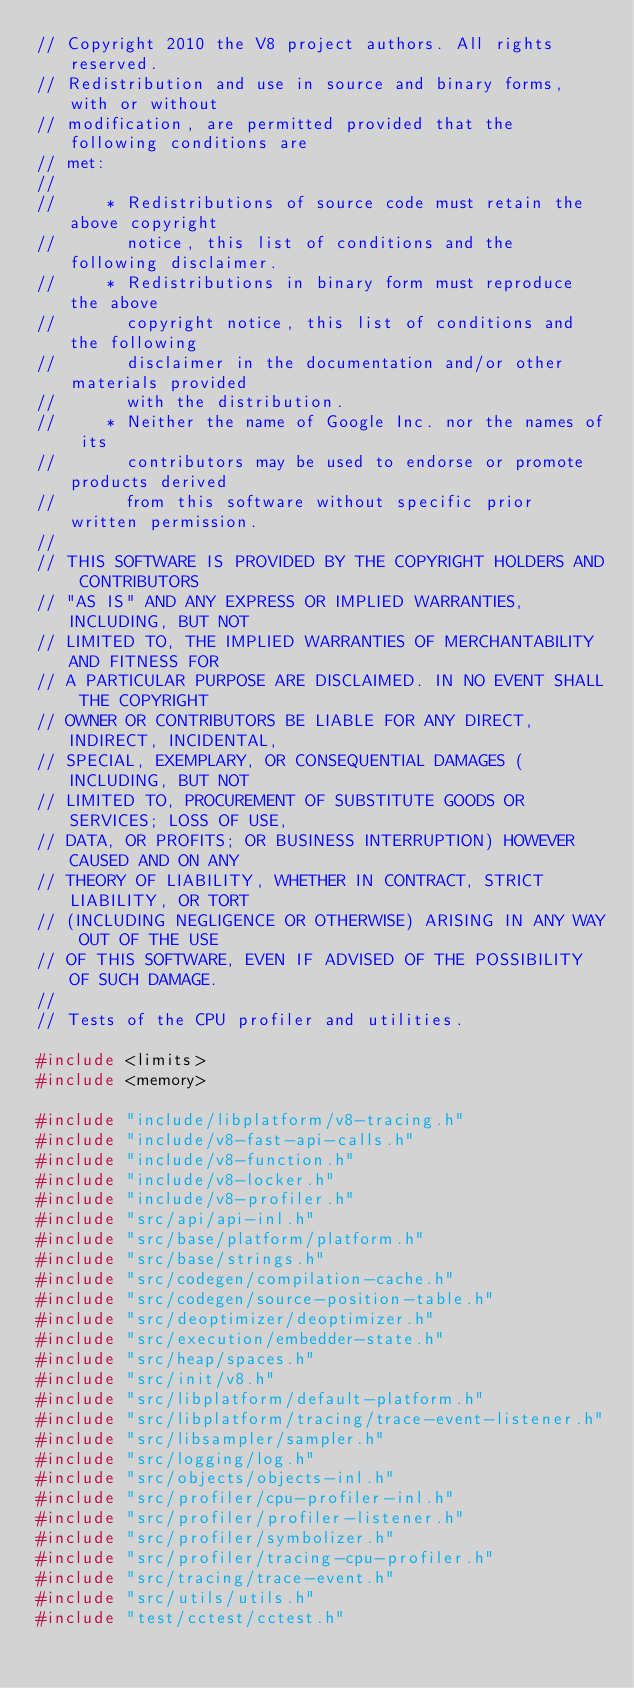<code> <loc_0><loc_0><loc_500><loc_500><_C++_>// Copyright 2010 the V8 project authors. All rights reserved.
// Redistribution and use in source and binary forms, with or without
// modification, are permitted provided that the following conditions are
// met:
//
//     * Redistributions of source code must retain the above copyright
//       notice, this list of conditions and the following disclaimer.
//     * Redistributions in binary form must reproduce the above
//       copyright notice, this list of conditions and the following
//       disclaimer in the documentation and/or other materials provided
//       with the distribution.
//     * Neither the name of Google Inc. nor the names of its
//       contributors may be used to endorse or promote products derived
//       from this software without specific prior written permission.
//
// THIS SOFTWARE IS PROVIDED BY THE COPYRIGHT HOLDERS AND CONTRIBUTORS
// "AS IS" AND ANY EXPRESS OR IMPLIED WARRANTIES, INCLUDING, BUT NOT
// LIMITED TO, THE IMPLIED WARRANTIES OF MERCHANTABILITY AND FITNESS FOR
// A PARTICULAR PURPOSE ARE DISCLAIMED. IN NO EVENT SHALL THE COPYRIGHT
// OWNER OR CONTRIBUTORS BE LIABLE FOR ANY DIRECT, INDIRECT, INCIDENTAL,
// SPECIAL, EXEMPLARY, OR CONSEQUENTIAL DAMAGES (INCLUDING, BUT NOT
// LIMITED TO, PROCUREMENT OF SUBSTITUTE GOODS OR SERVICES; LOSS OF USE,
// DATA, OR PROFITS; OR BUSINESS INTERRUPTION) HOWEVER CAUSED AND ON ANY
// THEORY OF LIABILITY, WHETHER IN CONTRACT, STRICT LIABILITY, OR TORT
// (INCLUDING NEGLIGENCE OR OTHERWISE) ARISING IN ANY WAY OUT OF THE USE
// OF THIS SOFTWARE, EVEN IF ADVISED OF THE POSSIBILITY OF SUCH DAMAGE.
//
// Tests of the CPU profiler and utilities.

#include <limits>
#include <memory>

#include "include/libplatform/v8-tracing.h"
#include "include/v8-fast-api-calls.h"
#include "include/v8-function.h"
#include "include/v8-locker.h"
#include "include/v8-profiler.h"
#include "src/api/api-inl.h"
#include "src/base/platform/platform.h"
#include "src/base/strings.h"
#include "src/codegen/compilation-cache.h"
#include "src/codegen/source-position-table.h"
#include "src/deoptimizer/deoptimizer.h"
#include "src/execution/embedder-state.h"
#include "src/heap/spaces.h"
#include "src/init/v8.h"
#include "src/libplatform/default-platform.h"
#include "src/libplatform/tracing/trace-event-listener.h"
#include "src/libsampler/sampler.h"
#include "src/logging/log.h"
#include "src/objects/objects-inl.h"
#include "src/profiler/cpu-profiler-inl.h"
#include "src/profiler/profiler-listener.h"
#include "src/profiler/symbolizer.h"
#include "src/profiler/tracing-cpu-profiler.h"
#include "src/tracing/trace-event.h"
#include "src/utils/utils.h"
#include "test/cctest/cctest.h"</code> 